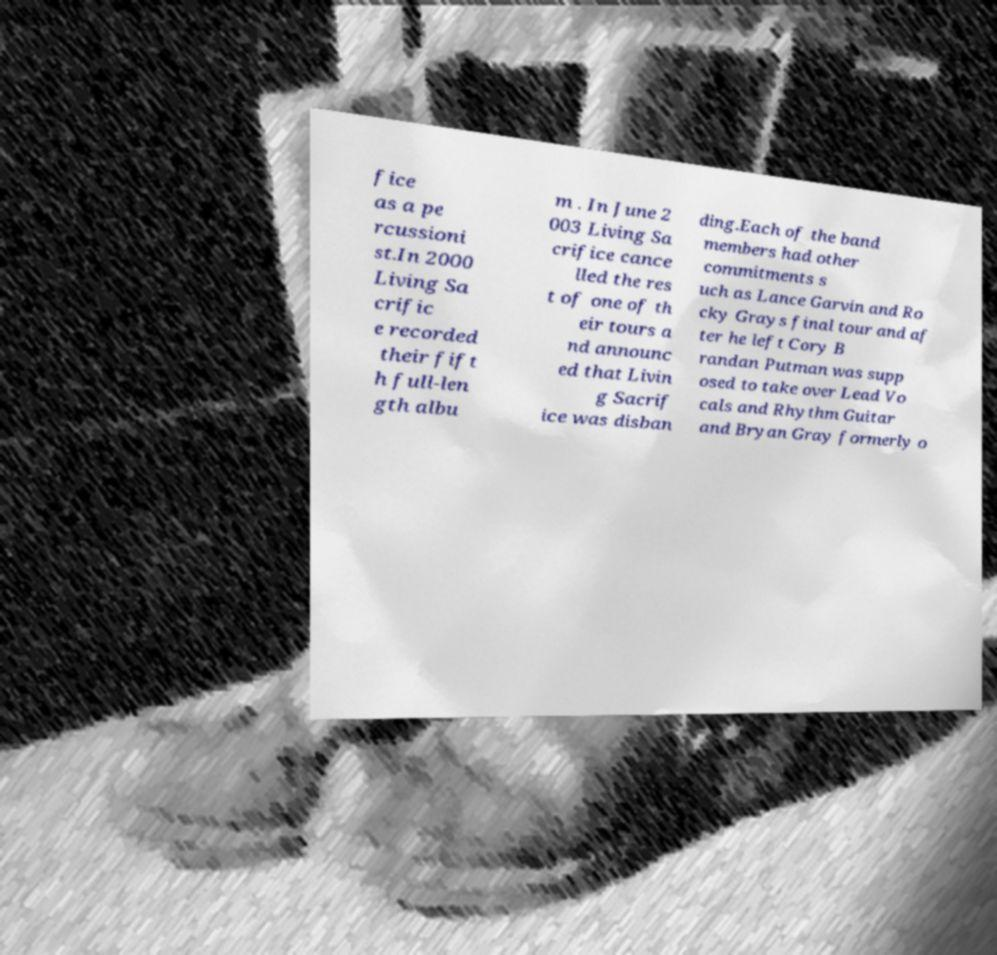There's text embedded in this image that I need extracted. Can you transcribe it verbatim? fice as a pe rcussioni st.In 2000 Living Sa crific e recorded their fift h full-len gth albu m . In June 2 003 Living Sa crifice cance lled the res t of one of th eir tours a nd announc ed that Livin g Sacrif ice was disban ding.Each of the band members had other commitments s uch as Lance Garvin and Ro cky Grays final tour and af ter he left Cory B randan Putman was supp osed to take over Lead Vo cals and Rhythm Guitar and Bryan Gray formerly o 